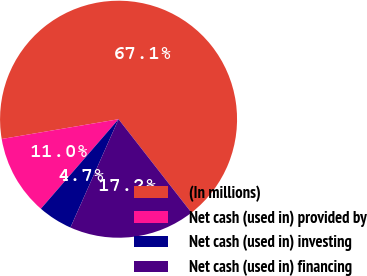Convert chart to OTSL. <chart><loc_0><loc_0><loc_500><loc_500><pie_chart><fcel>(In millions)<fcel>Net cash (used in) provided by<fcel>Net cash (used in) investing<fcel>Net cash (used in) financing<nl><fcel>67.13%<fcel>10.96%<fcel>4.72%<fcel>17.2%<nl></chart> 